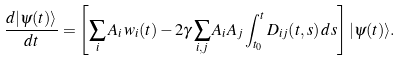Convert formula to latex. <formula><loc_0><loc_0><loc_500><loc_500>\frac { d | \psi ( t ) \rangle } { d t } = \left [ \sum _ { i } A _ { i } \, w _ { i } ( t ) - 2 \gamma \sum _ { i , j } A _ { i } A _ { j } \int _ { t _ { 0 } } ^ { t } D _ { i j } ( t , s ) \, d s \right ] | \psi ( t ) \rangle .</formula> 